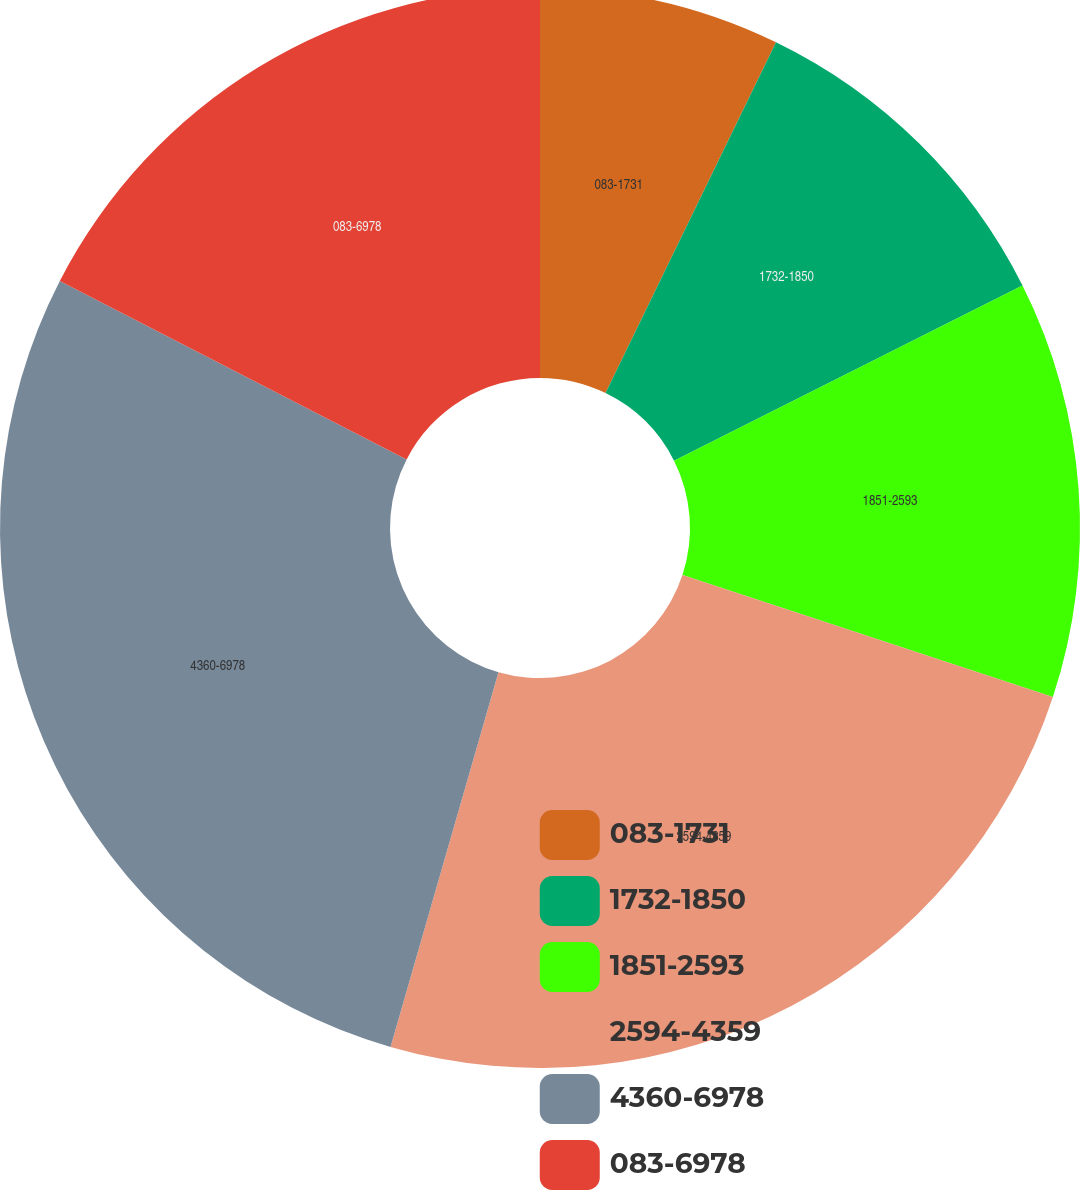Convert chart. <chart><loc_0><loc_0><loc_500><loc_500><pie_chart><fcel>083-1731<fcel>1732-1850<fcel>1851-2593<fcel>2594-4359<fcel>4360-6978<fcel>083-6978<nl><fcel>7.2%<fcel>10.39%<fcel>12.48%<fcel>24.4%<fcel>28.1%<fcel>17.44%<nl></chart> 